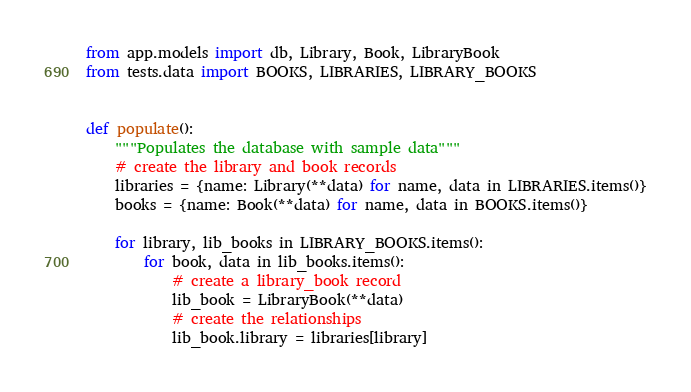Convert code to text. <code><loc_0><loc_0><loc_500><loc_500><_Python_>from app.models import db, Library, Book, LibraryBook
from tests.data import BOOKS, LIBRARIES, LIBRARY_BOOKS


def populate():
    """Populates the database with sample data"""
    # create the library and book records
    libraries = {name: Library(**data) for name, data in LIBRARIES.items()}
    books = {name: Book(**data) for name, data in BOOKS.items()}

    for library, lib_books in LIBRARY_BOOKS.items():
        for book, data in lib_books.items():
            # create a library_book record
            lib_book = LibraryBook(**data)
            # create the relationships
            lib_book.library = libraries[library]</code> 